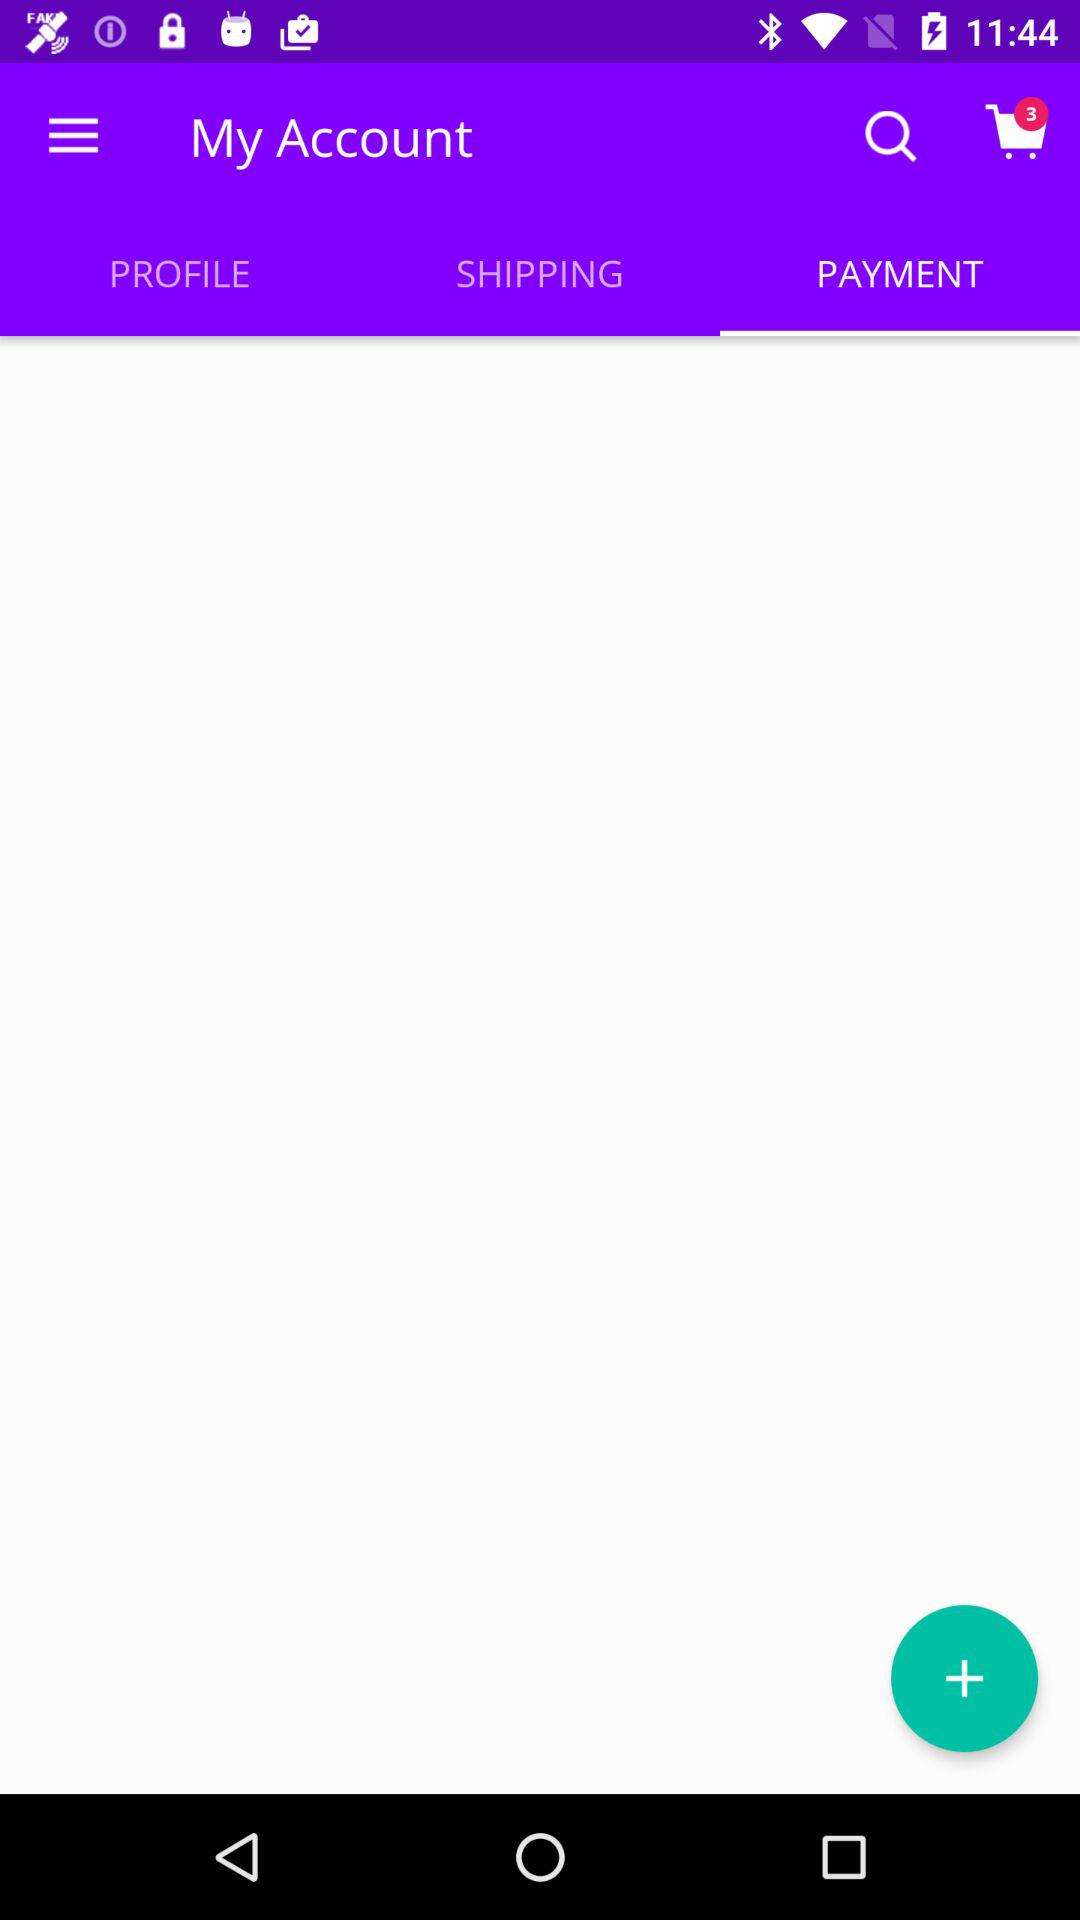How many items are in the shopping cart?
Answer the question using a single word or phrase. 3 